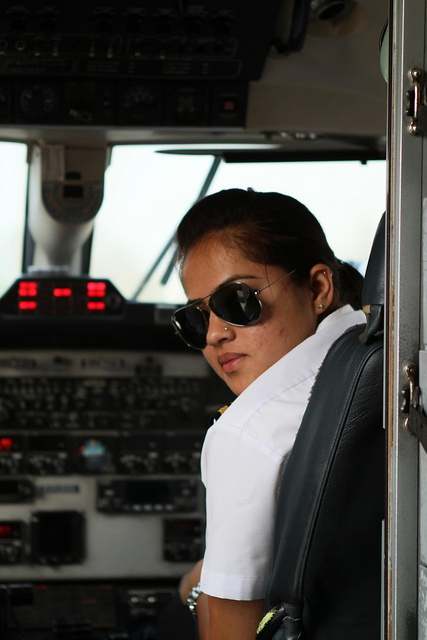Describe the objects in this image and their specific colors. I can see people in black, lightgray, brown, and maroon tones and chair in black, gray, and purple tones in this image. 